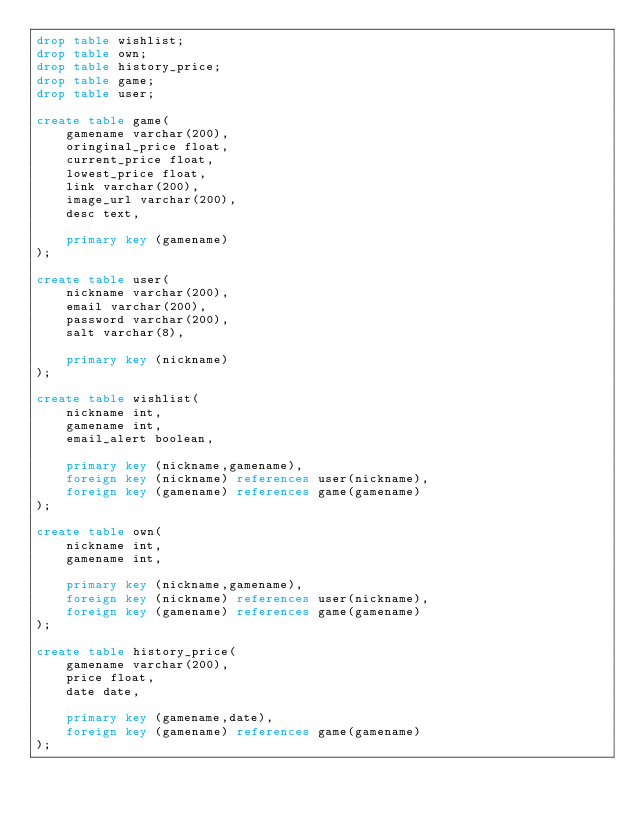<code> <loc_0><loc_0><loc_500><loc_500><_SQL_>drop table wishlist;
drop table own;
drop table history_price;
drop table game;
drop table user;

create table game(
    gamename varchar(200),
    oringinal_price float,
    current_price float,
    lowest_price float,
    link varchar(200),
    image_url varchar(200),
    desc text,

    primary key (gamename)
);

create table user(
    nickname varchar(200),
    email varchar(200),
    password varchar(200),
    salt varchar(8),

    primary key (nickname)
);

create table wishlist(
    nickname int,
    gamename int,
    email_alert boolean,

    primary key (nickname,gamename),
    foreign key (nickname) references user(nickname),
    foreign key (gamename) references game(gamename)
);

create table own(
    nickname int,
    gamename int,

    primary key (nickname,gamename),
    foreign key (nickname) references user(nickname),
    foreign key (gamename) references game(gamename)
);

create table history_price(
    gamename varchar(200),
    price float,
    date date,

    primary key (gamename,date),
    foreign key (gamename) references game(gamename)
);
</code> 